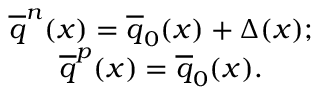Convert formula to latex. <formula><loc_0><loc_0><loc_500><loc_500>\begin{array} { c l c r } { { \overline { q } ^ { n } ( x ) = \overline { q } _ { 0 } ( x ) + \Delta ( x ) ; } } \\ { { \overline { q } ^ { p } ( x ) = \overline { q } _ { 0 } ( x ) . } } \end{array}</formula> 